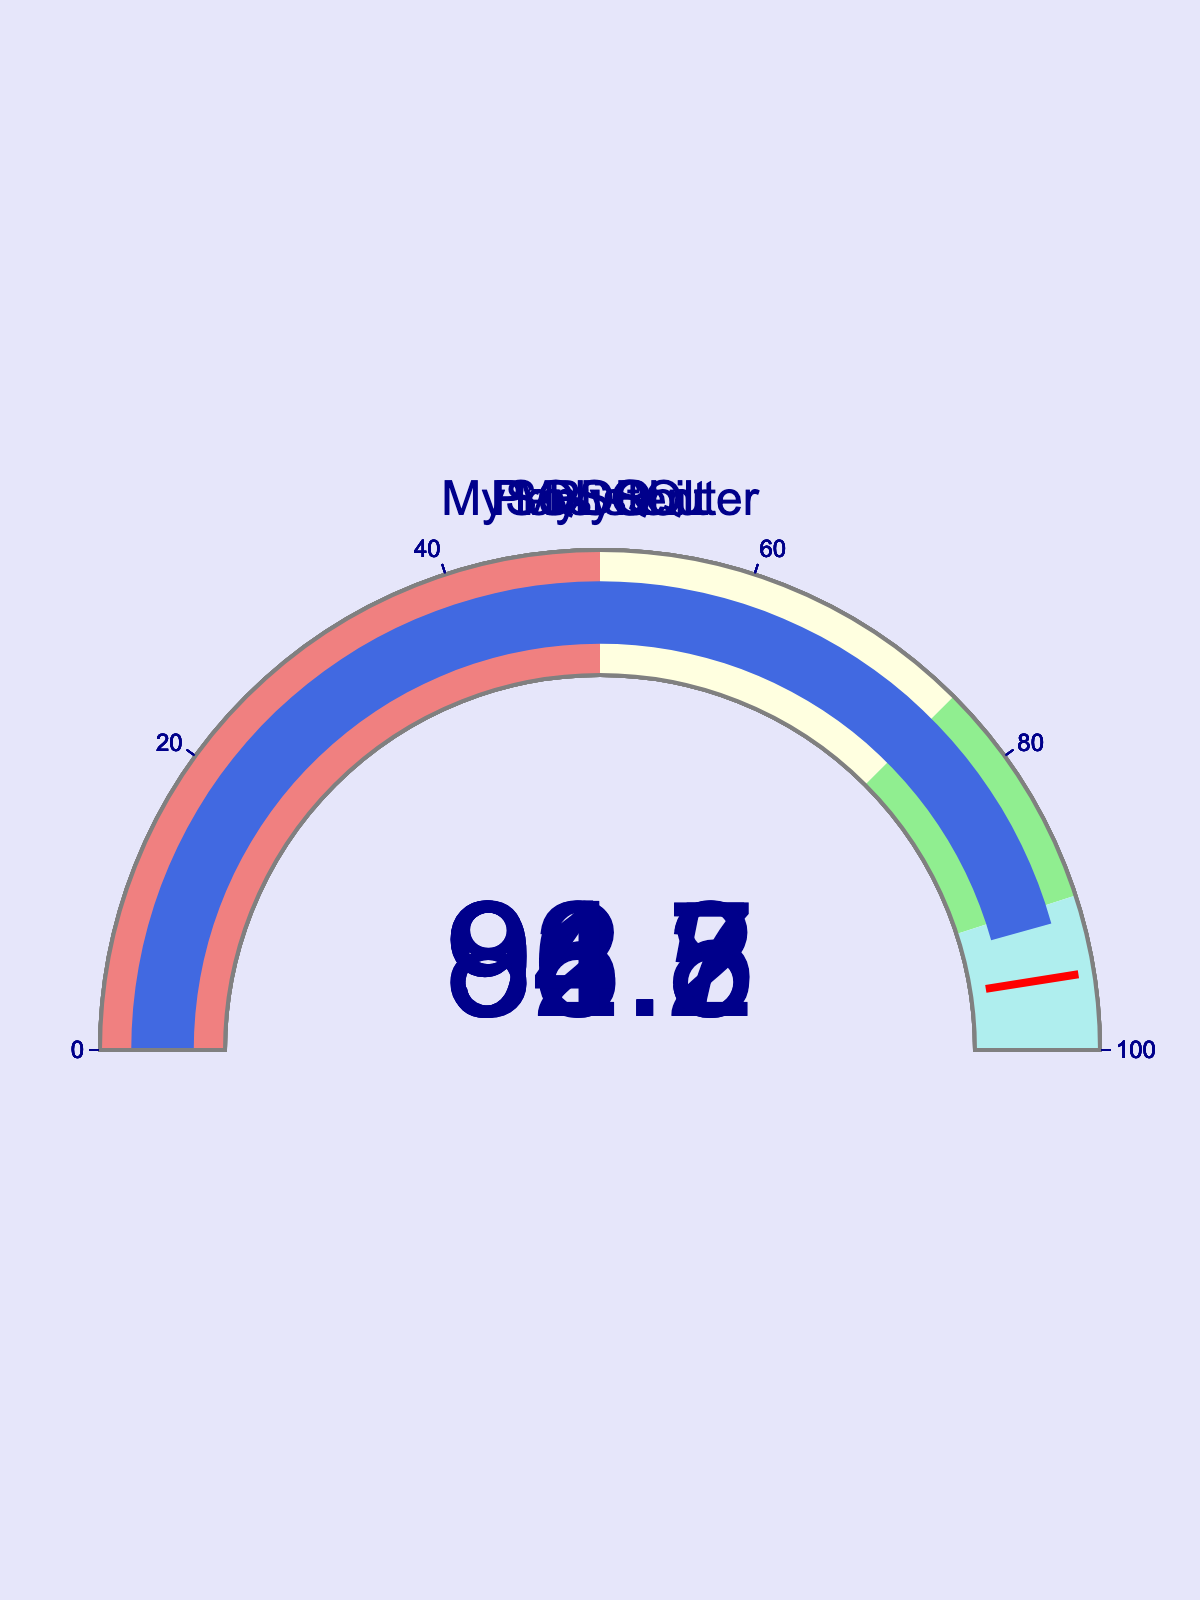What's the Efficiency Rate for the 'ProxySQL' connection type? Check the gauge labeled 'ProxySQL' and read the number displayed on it
Answer: 94.8 Which connection type has the highest MySQL connection pool efficiency rate? Compare the values shown in the gauges for all connection types and identify the highest one
Answer: ProxySQL What is the difference in efficiency rate between 'Persistent' and 'PDO'? Look at the efficiency rates for both 'Persistent' and 'PDO', then subtract PDO's rate from Persistent's rate (92.5 - 88.7)
Answer: 3.8 How many different connection types are shown in the figure? Count the number of gauges, as each represents a different connection type
Answer: 5 Is the efficiency rate of 'MySQLi' above the threshold value indicated in the figure? Compare 'MySQLi' efficiency rate (86.2) with the threshold value (95). Since 86.2 is lower than 95, it is not above the threshold
Answer: No Which two connection types have efficiency rates closest to each other? Find the difference between the efficiency rates for each pair and identify the smallest one. The closest rates are 'Persistent' (92.5) and 'MySQL Router' (91.3) with a difference of 1.2
Answer: Persistent and MySQL Router What is the efficiency rate range for the connection types in this figure? Determine the minimum and maximum efficiency rates from the gauges. The minimum is 'MySQLi' at 86.2 and the maximum is 'ProxySQL' at 94.8. The range is 94.8 - 86.2
Answer: 8.6 What's the average efficiency rate of all the connection types? Sum the efficiency rates of all the connection types and divide by the number of types: (92.5 + 88.7 + 86.2 + 94.8 + 91.3) / 5
Answer: 90.7 How does the color of the efficiency rate bar appear for the 'MySQL Router' gauge? Look at the color of the bar inside the 'MySQL Router' gauge, which is indicated to be "royalblue" in appearance based on the configuration
Answer: Royalblue What color is the gauge background for all the connection types? Observe the overall appearance of the gauges. The background color is consistently white for all gauges as configured
Answer: White 